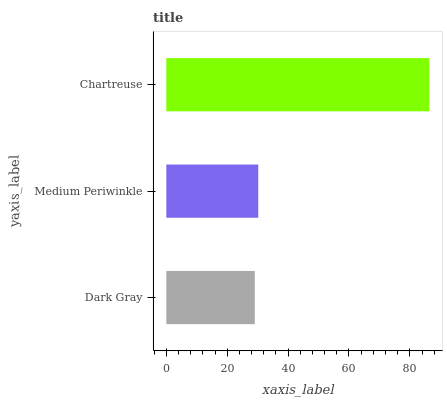Is Dark Gray the minimum?
Answer yes or no. Yes. Is Chartreuse the maximum?
Answer yes or no. Yes. Is Medium Periwinkle the minimum?
Answer yes or no. No. Is Medium Periwinkle the maximum?
Answer yes or no. No. Is Medium Periwinkle greater than Dark Gray?
Answer yes or no. Yes. Is Dark Gray less than Medium Periwinkle?
Answer yes or no. Yes. Is Dark Gray greater than Medium Periwinkle?
Answer yes or no. No. Is Medium Periwinkle less than Dark Gray?
Answer yes or no. No. Is Medium Periwinkle the high median?
Answer yes or no. Yes. Is Medium Periwinkle the low median?
Answer yes or no. Yes. Is Dark Gray the high median?
Answer yes or no. No. Is Chartreuse the low median?
Answer yes or no. No. 